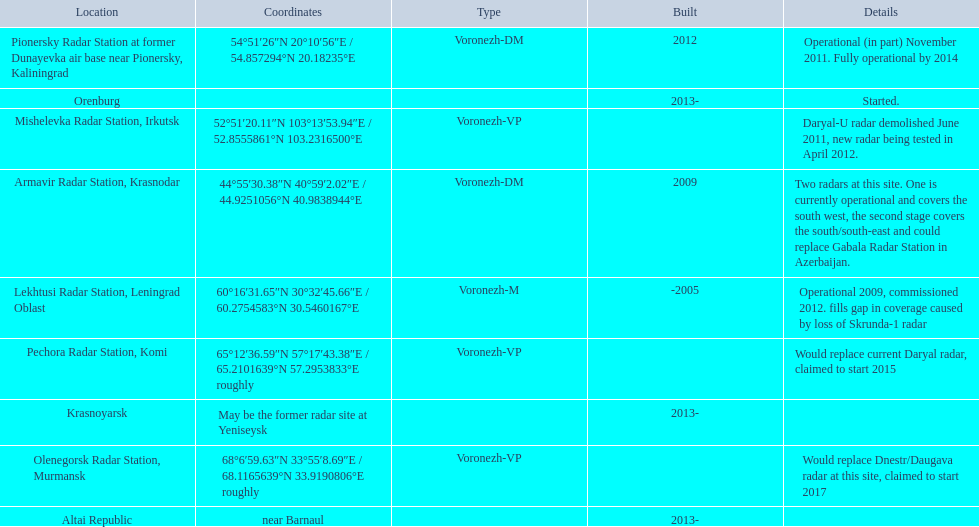Voronezh radar has locations where? Lekhtusi Radar Station, Leningrad Oblast, Armavir Radar Station, Krasnodar, Pionersky Radar Station at former Dunayevka air base near Pionersky, Kaliningrad, Mishelevka Radar Station, Irkutsk, Pechora Radar Station, Komi, Olenegorsk Radar Station, Murmansk, Krasnoyarsk, Altai Republic, Orenburg. Which of these locations have know coordinates? Lekhtusi Radar Station, Leningrad Oblast, Armavir Radar Station, Krasnodar, Pionersky Radar Station at former Dunayevka air base near Pionersky, Kaliningrad, Mishelevka Radar Station, Irkutsk, Pechora Radar Station, Komi, Olenegorsk Radar Station, Murmansk. Which of these locations has coordinates of 60deg16'31.65''n 30deg32'45.66''e / 60.2754583degn 30.5460167dege? Lekhtusi Radar Station, Leningrad Oblast. 